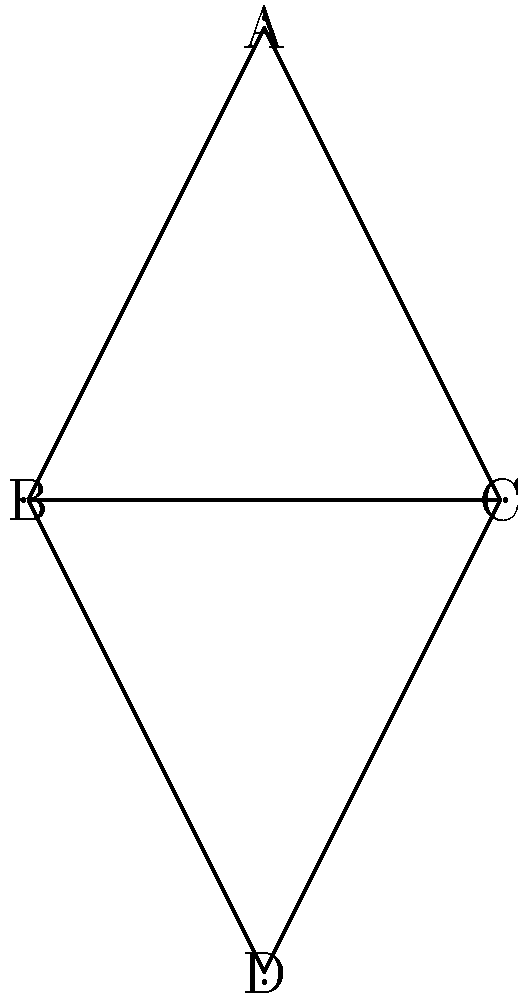Consider the network diagram representing conflicting viewpoints between a talk show host and a newspaper columnist. The nodes represent different perspectives, and the edges represent connections or conflicts between them. What is the order of the automorphism group of this network? To determine the order of the automorphism group, we need to follow these steps:

1) First, observe the symmetry of the graph. The graph has a vertical axis of symmetry.

2) Identify the possible automorphisms:
   a) The identity automorphism (leaves all nodes in place)
   b) The automorphism that swaps B and C, while leaving A and D fixed

3) Let's verify that these are the only automorphisms:
   - A must be fixed because it's the only node with degree 2
   - D must be fixed because it's the only node not connected to A
   - B and C are interchangeable due to the symmetry

4) Count the number of automorphisms:
   - Identity automorphism: 1
   - B-C swap: 1

5) The total number of automorphisms is 1 + 1 = 2

6) The order of the automorphism group is equal to the number of automorphisms.

Therefore, the order of the automorphism group is 2.
Answer: 2 